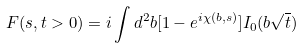<formula> <loc_0><loc_0><loc_500><loc_500>F ( s , t > 0 ) = i \int d ^ { 2 } { b } [ 1 - e ^ { i \chi ( b , s ) } ] I _ { 0 } ( b \sqrt { t } )</formula> 